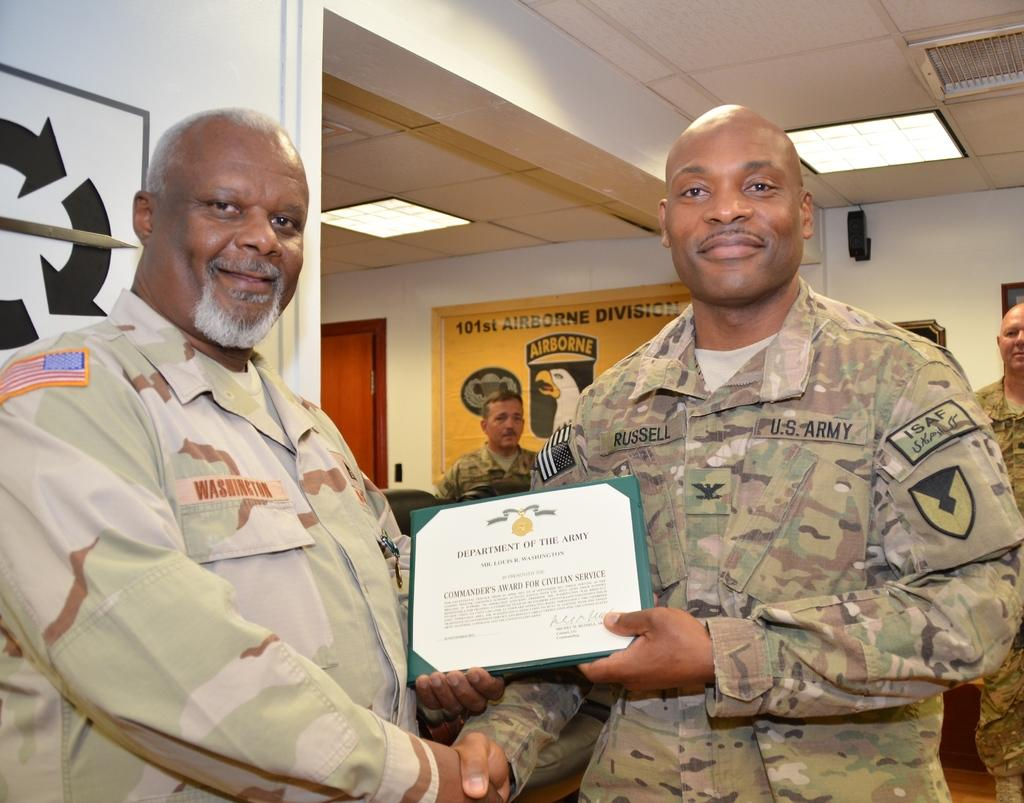Where was the image taken? The image was taken inside a room. What can be seen at the top of the room? There are lights at the top of the room. How many people are in the image? There are two persons in the image. What are the two persons wearing? The two persons are wearing army dresses. What are the two persons holding in the image? The two persons are holding some paper. What type of jelly is being served on the table in the image? There is no table or jelly present in the image. Can you describe the mouth of the person on the left in the image? There is no reference to a person's mouth in the image, as it only shows two persons wearing army dresses and holding some paper. 